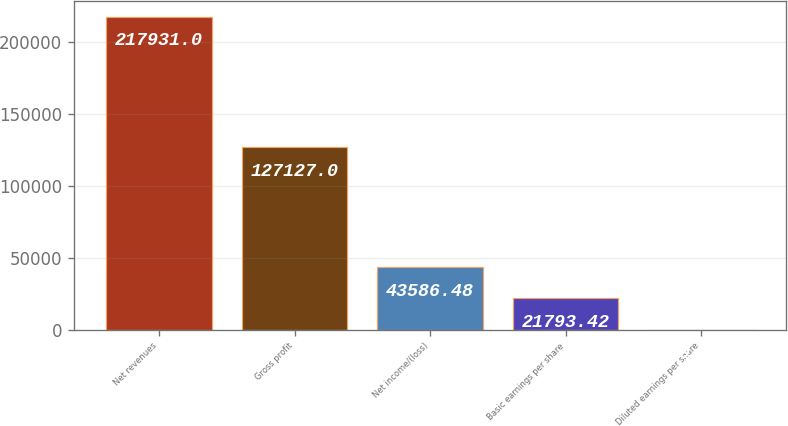<chart> <loc_0><loc_0><loc_500><loc_500><bar_chart><fcel>Net revenues<fcel>Gross profit<fcel>Net income/(loss)<fcel>Basic earnings per share<fcel>Diluted earnings per share<nl><fcel>217931<fcel>127127<fcel>43586.5<fcel>21793.4<fcel>0.36<nl></chart> 